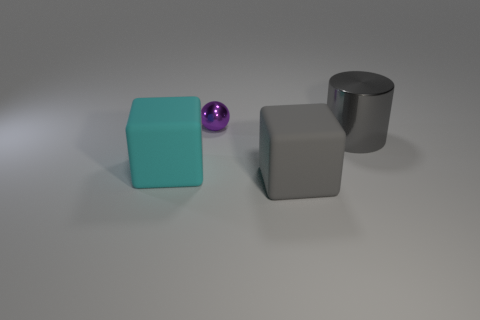Does the ball have the same color as the large shiny cylinder?
Your answer should be very brief. No. What is the size of the metallic object on the left side of the metallic cylinder?
Your answer should be compact. Small. Are there any other things of the same color as the metallic ball?
Provide a succinct answer. No. Is there a large block behind the large rubber object that is left of the small purple metallic thing that is behind the big metal cylinder?
Offer a terse response. No. Does the big cube that is on the left side of the gray rubber thing have the same color as the tiny shiny sphere?
Make the answer very short. No. How many cubes are large rubber objects or tiny purple shiny objects?
Provide a short and direct response. 2. The tiny purple object that is behind the big rubber block that is to the left of the small purple shiny ball is what shape?
Keep it short and to the point. Sphere. How big is the shiny thing that is on the left side of the big matte object on the right side of the big cyan rubber cube on the left side of the gray cylinder?
Your answer should be very brief. Small. Does the cyan cube have the same size as the purple ball?
Your response must be concise. No. How many objects are large rubber cubes or tiny purple balls?
Your answer should be very brief. 3. 